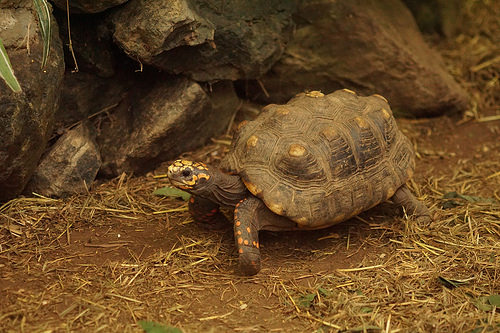<image>
Can you confirm if the rock is to the right of the turtle? Yes. From this viewpoint, the rock is positioned to the right side relative to the turtle. 